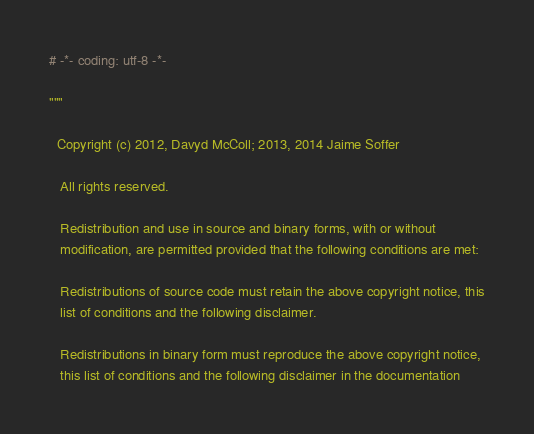<code> <loc_0><loc_0><loc_500><loc_500><_Python_># -*- coding: utf-8 -*-

"""

  Copyright (c) 2012, Davyd McColl; 2013, 2014 Jaime Soffer

   All rights reserved.

   Redistribution and use in source and binary forms, with or without
   modification, are permitted provided that the following conditions are met:

   Redistributions of source code must retain the above copyright notice, this
   list of conditions and the following disclaimer.

   Redistributions in binary form must reproduce the above copyright notice,
   this list of conditions and the following disclaimer in the documentation</code> 